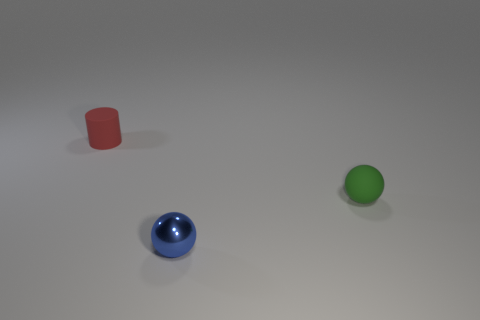What can you say about the lighting in the scene? The lighting appears soft and diffuse, producing gentle shadows beneath the objects, indicating an overhead light source without harsh direct lighting. 